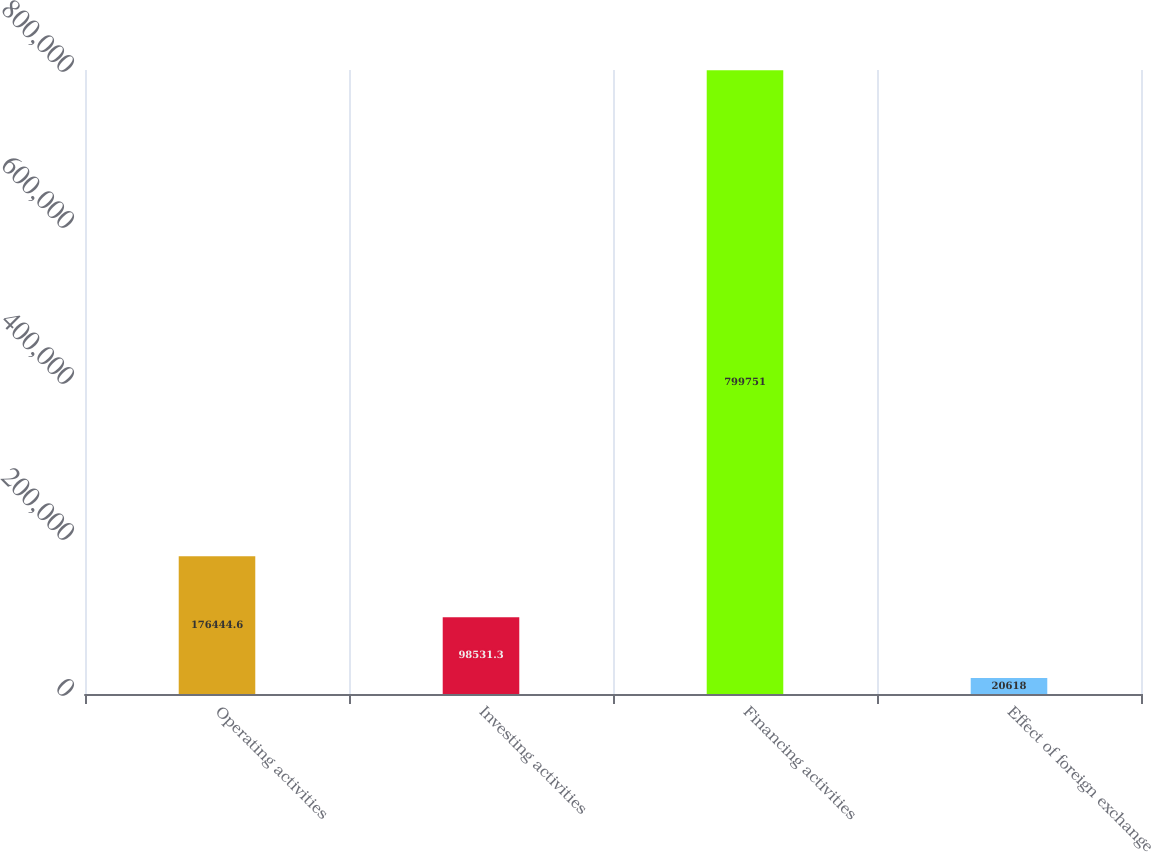Convert chart. <chart><loc_0><loc_0><loc_500><loc_500><bar_chart><fcel>Operating activities<fcel>Investing activities<fcel>Financing activities<fcel>Effect of foreign exchange<nl><fcel>176445<fcel>98531.3<fcel>799751<fcel>20618<nl></chart> 